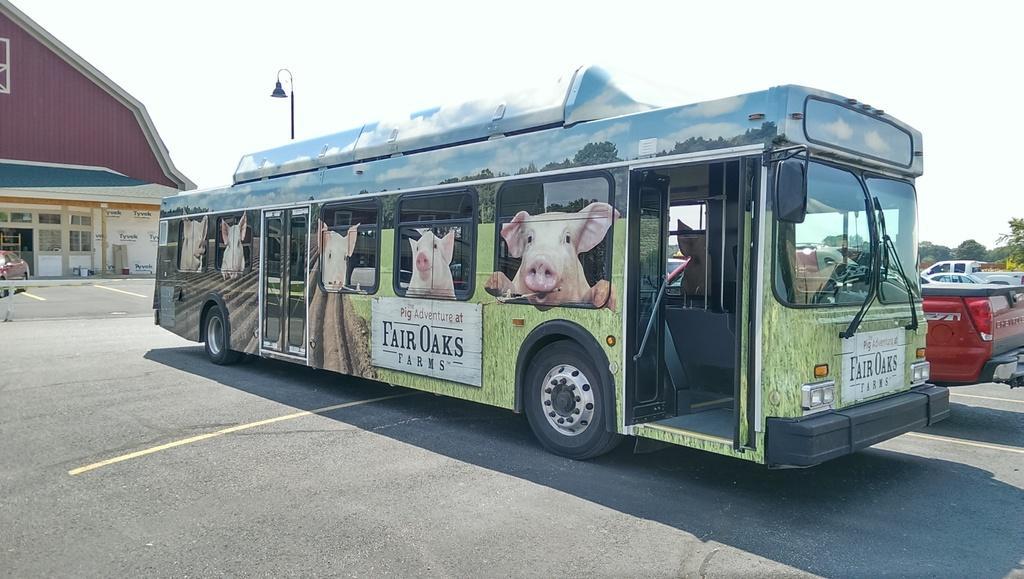In one or two sentences, can you explain what this image depicts? In this image we can see a bus on which we can see pig images. Here we can see a few more vehicles parked, here we can see trees, light poles, house and the sky in the background. 